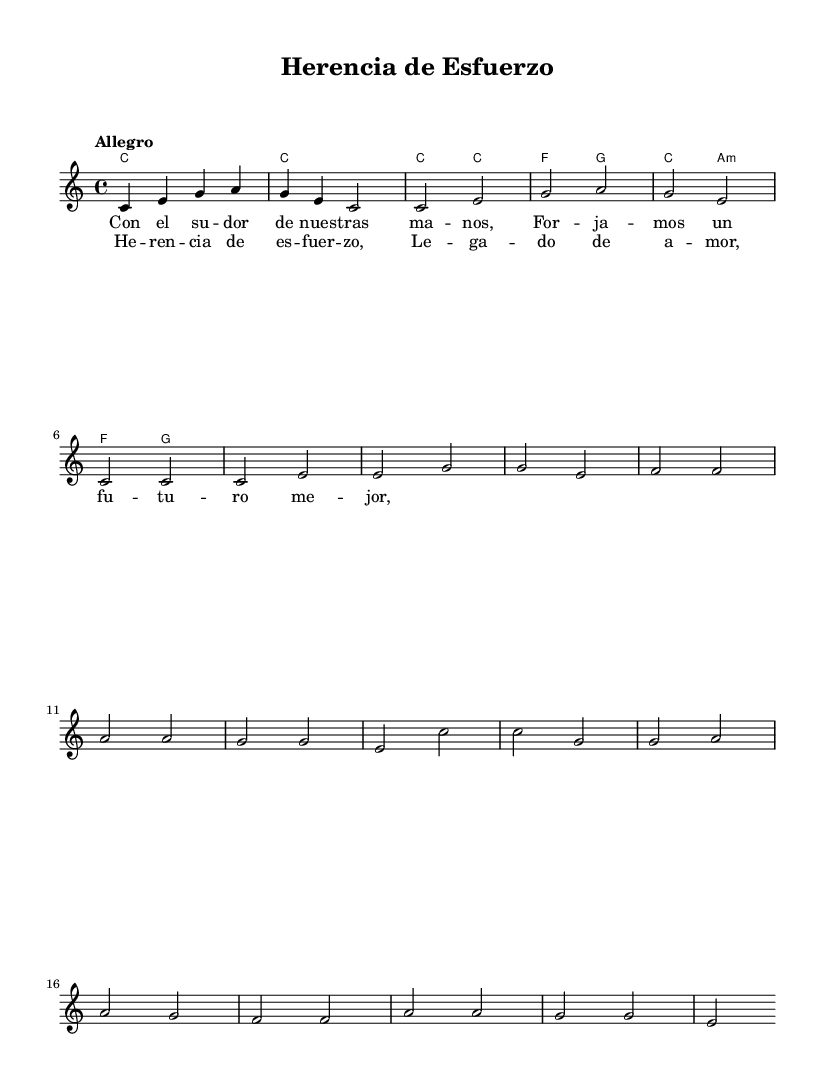What is the key signature of this music? The key signature is C major, which has no sharps or flats.
Answer: C major What is the time signature of this piece? The time signature is indicated as 4/4, meaning there are four beats per measure.
Answer: 4/4 What is the tempo marking for this piece? The tempo marking is "Allegro," which indicates a fast tempo.
Answer: Allegro How many measures are in the chorus section? By examining the music, the chorus consists of 4 measures, with repeated lyrics indicating a complete section.
Answer: 4 What musical form does this anthem follow? The anthem follows a structure common in popular music, which consists of verses followed by a repeated chorus.
Answer: Verse-Chorus What theme is represented in the lyrics of the first verse? The first verse speaks about working together and making a better future, highlighting unity and aspiration.
Answer: Unity and aspiration What is the emotional tone described in the chorus? The chorus conveys a tone of pride and legacy, emphasizing strength in perseverance and family bonds.
Answer: Pride and legacy 